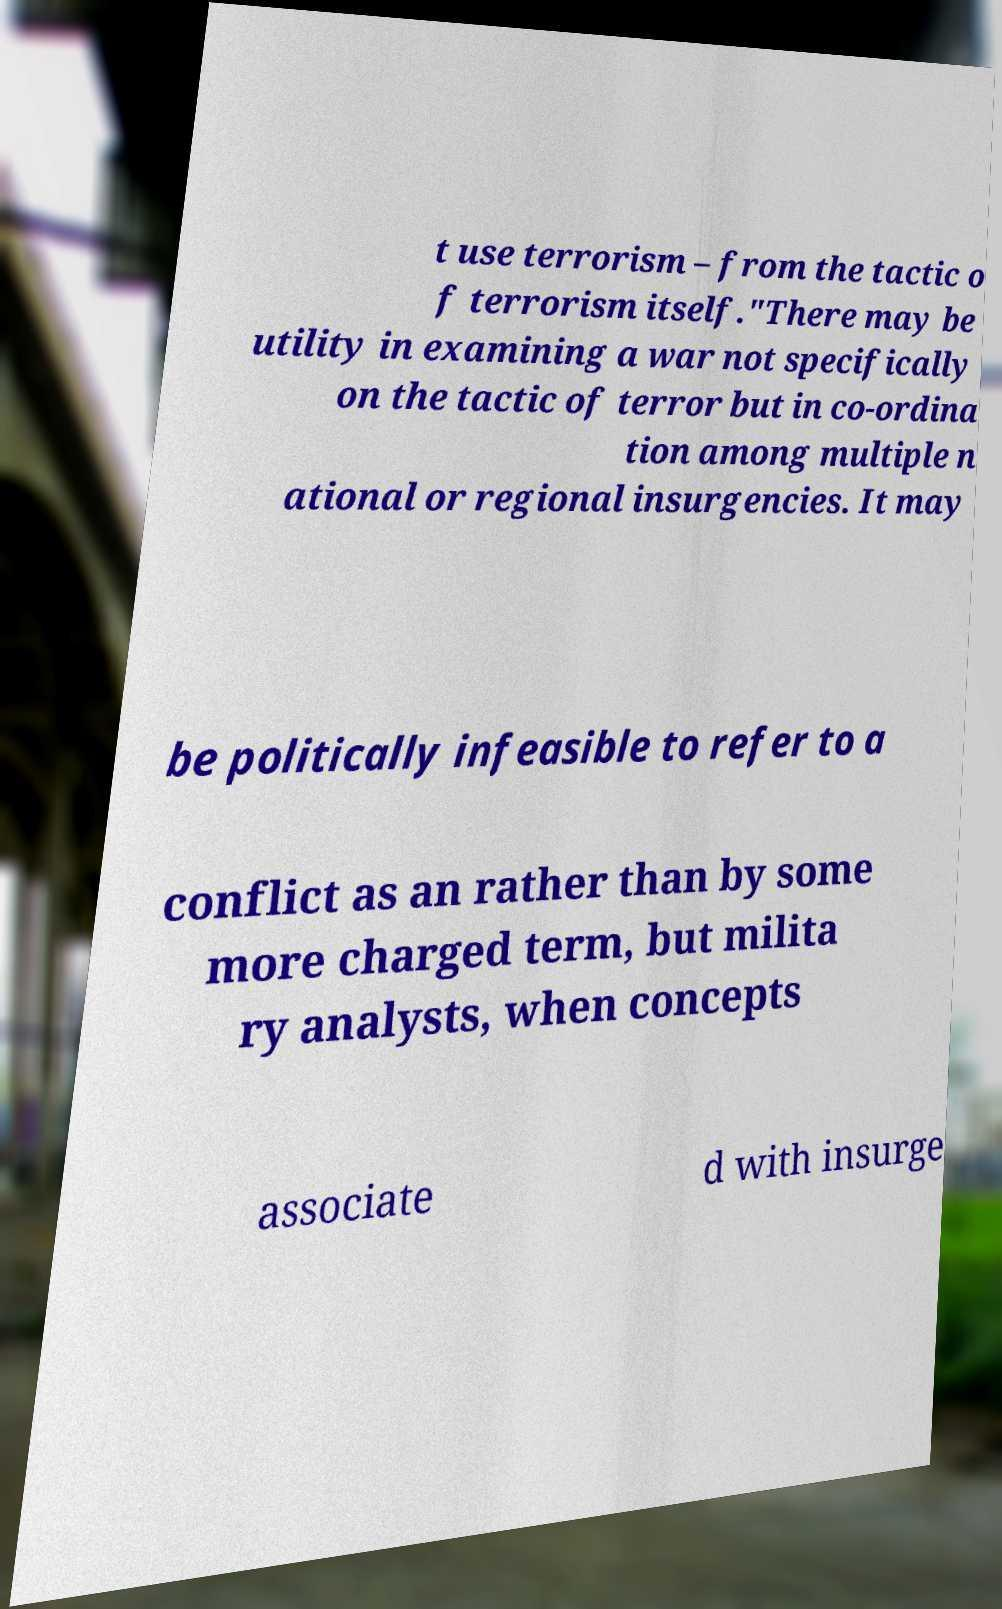What messages or text are displayed in this image? I need them in a readable, typed format. t use terrorism – from the tactic o f terrorism itself."There may be utility in examining a war not specifically on the tactic of terror but in co-ordina tion among multiple n ational or regional insurgencies. It may be politically infeasible to refer to a conflict as an rather than by some more charged term, but milita ry analysts, when concepts associate d with insurge 